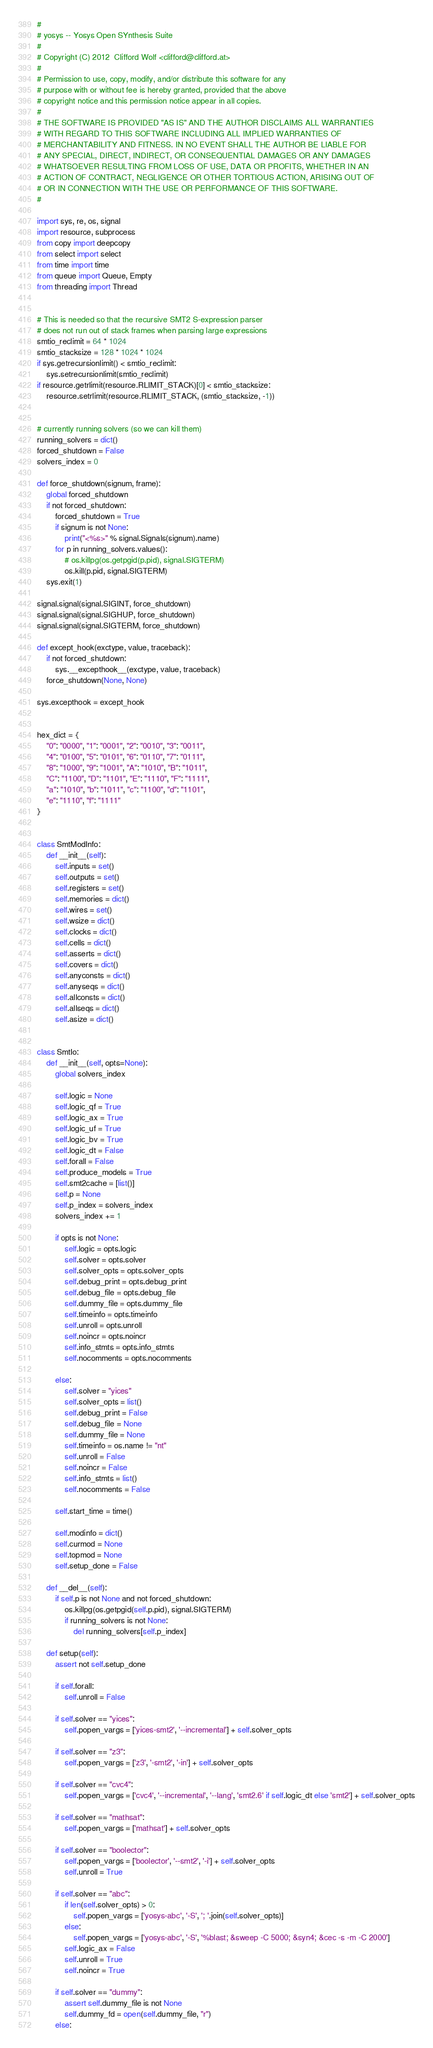<code> <loc_0><loc_0><loc_500><loc_500><_Python_>#
# yosys -- Yosys Open SYnthesis Suite
#
# Copyright (C) 2012  Clifford Wolf <clifford@clifford.at>
#
# Permission to use, copy, modify, and/or distribute this software for any
# purpose with or without fee is hereby granted, provided that the above
# copyright notice and this permission notice appear in all copies.
#
# THE SOFTWARE IS PROVIDED "AS IS" AND THE AUTHOR DISCLAIMS ALL WARRANTIES
# WITH REGARD TO THIS SOFTWARE INCLUDING ALL IMPLIED WARRANTIES OF
# MERCHANTABILITY AND FITNESS. IN NO EVENT SHALL THE AUTHOR BE LIABLE FOR
# ANY SPECIAL, DIRECT, INDIRECT, OR CONSEQUENTIAL DAMAGES OR ANY DAMAGES
# WHATSOEVER RESULTING FROM LOSS OF USE, DATA OR PROFITS, WHETHER IN AN
# ACTION OF CONTRACT, NEGLIGENCE OR OTHER TORTIOUS ACTION, ARISING OUT OF
# OR IN CONNECTION WITH THE USE OR PERFORMANCE OF THIS SOFTWARE.
#

import sys, re, os, signal
import resource, subprocess
from copy import deepcopy
from select import select
from time import time
from queue import Queue, Empty
from threading import Thread


# This is needed so that the recursive SMT2 S-expression parser
# does not run out of stack frames when parsing large expressions
smtio_reclimit = 64 * 1024
smtio_stacksize = 128 * 1024 * 1024
if sys.getrecursionlimit() < smtio_reclimit:
    sys.setrecursionlimit(smtio_reclimit)
if resource.getrlimit(resource.RLIMIT_STACK)[0] < smtio_stacksize:
    resource.setrlimit(resource.RLIMIT_STACK, (smtio_stacksize, -1))


# currently running solvers (so we can kill them)
running_solvers = dict()
forced_shutdown = False
solvers_index = 0

def force_shutdown(signum, frame):
    global forced_shutdown
    if not forced_shutdown:
        forced_shutdown = True
        if signum is not None:
            print("<%s>" % signal.Signals(signum).name)
        for p in running_solvers.values():
            # os.killpg(os.getpgid(p.pid), signal.SIGTERM)
            os.kill(p.pid, signal.SIGTERM)
    sys.exit(1)

signal.signal(signal.SIGINT, force_shutdown)
signal.signal(signal.SIGHUP, force_shutdown)
signal.signal(signal.SIGTERM, force_shutdown)

def except_hook(exctype, value, traceback):
    if not forced_shutdown:
        sys.__excepthook__(exctype, value, traceback)
    force_shutdown(None, None)

sys.excepthook = except_hook


hex_dict = {
    "0": "0000", "1": "0001", "2": "0010", "3": "0011",
    "4": "0100", "5": "0101", "6": "0110", "7": "0111",
    "8": "1000", "9": "1001", "A": "1010", "B": "1011",
    "C": "1100", "D": "1101", "E": "1110", "F": "1111",
    "a": "1010", "b": "1011", "c": "1100", "d": "1101",
    "e": "1110", "f": "1111"
}


class SmtModInfo:
    def __init__(self):
        self.inputs = set()
        self.outputs = set()
        self.registers = set()
        self.memories = dict()
        self.wires = set()
        self.wsize = dict()
        self.clocks = dict()
        self.cells = dict()
        self.asserts = dict()
        self.covers = dict()
        self.anyconsts = dict()
        self.anyseqs = dict()
        self.allconsts = dict()
        self.allseqs = dict()
        self.asize = dict()


class SmtIo:
    def __init__(self, opts=None):
        global solvers_index

        self.logic = None
        self.logic_qf = True
        self.logic_ax = True
        self.logic_uf = True
        self.logic_bv = True
        self.logic_dt = False
        self.forall = False
        self.produce_models = True
        self.smt2cache = [list()]
        self.p = None
        self.p_index = solvers_index
        solvers_index += 1

        if opts is not None:
            self.logic = opts.logic
            self.solver = opts.solver
            self.solver_opts = opts.solver_opts
            self.debug_print = opts.debug_print
            self.debug_file = opts.debug_file
            self.dummy_file = opts.dummy_file
            self.timeinfo = opts.timeinfo
            self.unroll = opts.unroll
            self.noincr = opts.noincr
            self.info_stmts = opts.info_stmts
            self.nocomments = opts.nocomments

        else:
            self.solver = "yices"
            self.solver_opts = list()
            self.debug_print = False
            self.debug_file = None
            self.dummy_file = None
            self.timeinfo = os.name != "nt"
            self.unroll = False
            self.noincr = False
            self.info_stmts = list()
            self.nocomments = False

        self.start_time = time()

        self.modinfo = dict()
        self.curmod = None
        self.topmod = None
        self.setup_done = False

    def __del__(self):
        if self.p is not None and not forced_shutdown:
            os.killpg(os.getpgid(self.p.pid), signal.SIGTERM)
            if running_solvers is not None:
                del running_solvers[self.p_index]

    def setup(self):
        assert not self.setup_done

        if self.forall:
            self.unroll = False

        if self.solver == "yices":
            self.popen_vargs = ['yices-smt2', '--incremental'] + self.solver_opts

        if self.solver == "z3":
            self.popen_vargs = ['z3', '-smt2', '-in'] + self.solver_opts

        if self.solver == "cvc4":
            self.popen_vargs = ['cvc4', '--incremental', '--lang', 'smt2.6' if self.logic_dt else 'smt2'] + self.solver_opts

        if self.solver == "mathsat":
            self.popen_vargs = ['mathsat'] + self.solver_opts

        if self.solver == "boolector":
            self.popen_vargs = ['boolector', '--smt2', '-i'] + self.solver_opts
            self.unroll = True

        if self.solver == "abc":
            if len(self.solver_opts) > 0:
                self.popen_vargs = ['yosys-abc', '-S', '; '.join(self.solver_opts)]
            else:
                self.popen_vargs = ['yosys-abc', '-S', '%blast; &sweep -C 5000; &syn4; &cec -s -m -C 2000']
            self.logic_ax = False
            self.unroll = True
            self.noincr = True

        if self.solver == "dummy":
            assert self.dummy_file is not None
            self.dummy_fd = open(self.dummy_file, "r")
        else:</code> 